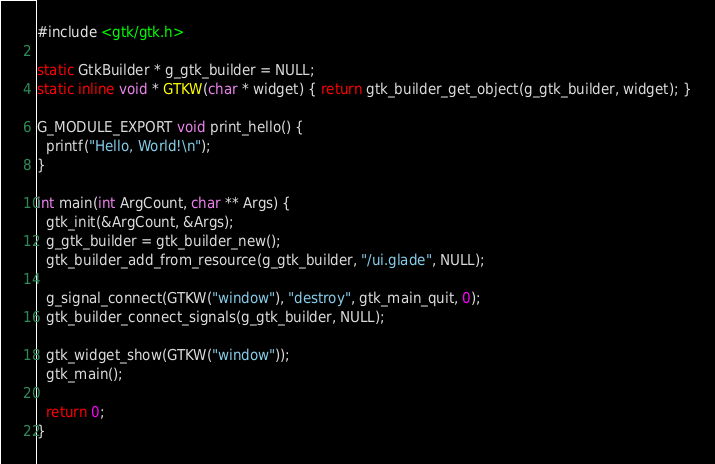<code> <loc_0><loc_0><loc_500><loc_500><_C_>#include <gtk/gtk.h>

static GtkBuilder * g_gtk_builder = NULL;
static inline void * GTKW(char * widget) { return gtk_builder_get_object(g_gtk_builder, widget); }

G_MODULE_EXPORT void print_hello() {
  printf("Hello, World!\n");
}

int main(int ArgCount, char ** Args) {
  gtk_init(&ArgCount, &Args);
  g_gtk_builder = gtk_builder_new();
  gtk_builder_add_from_resource(g_gtk_builder, "/ui.glade", NULL);

  g_signal_connect(GTKW("window"), "destroy", gtk_main_quit, 0);
  gtk_builder_connect_signals(g_gtk_builder, NULL);

  gtk_widget_show(GTKW("window"));
  gtk_main();

  return 0;
}
</code> 